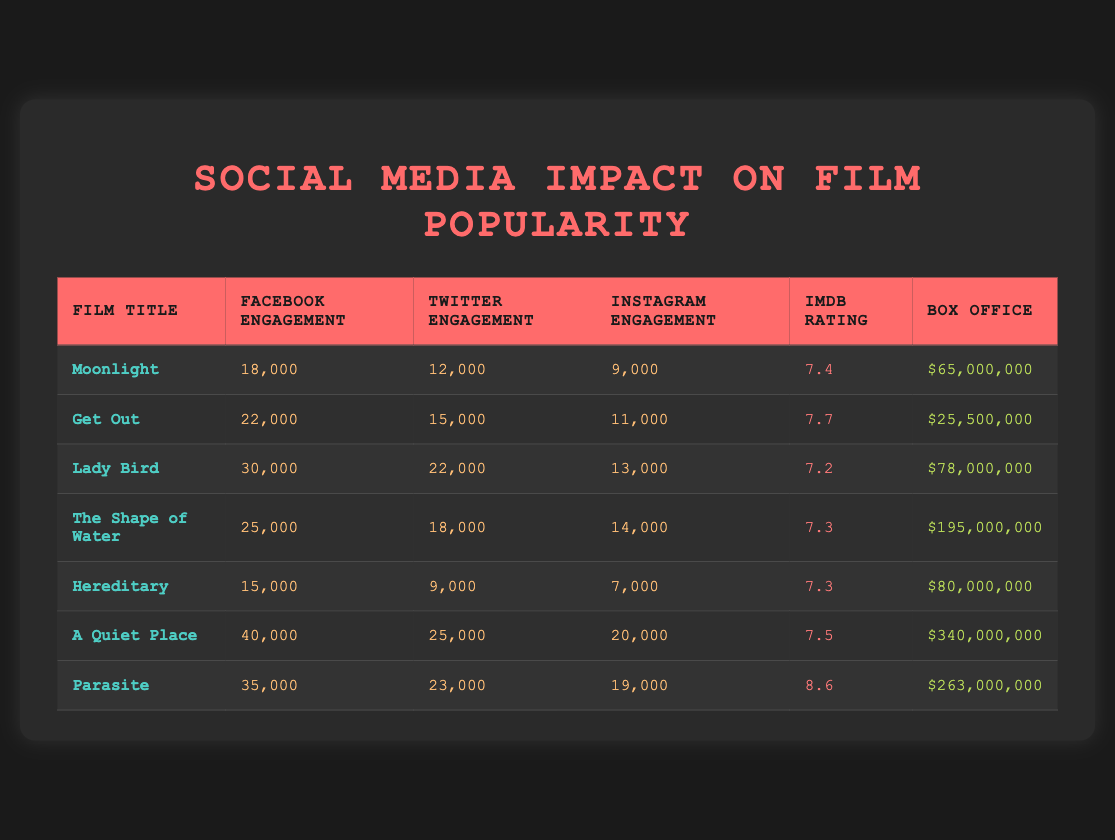What is the box office gross of "A Quiet Place"? The table shows that the box office for "A Quiet Place" is listed as $340,000,000.
Answer: $340,000,000 What film has the highest IMDb rating? By examining the IMDb ratings listed in the table, "Parasite" has the highest rating of 8.6 compared to the other films.
Answer: Parasite Which film had the least engagement on Facebook? Looking at the Facebook engagement values in the table, "Hereditary" has the lowest engagement at 15,000.
Answer: Hereditary What is the total box office gross of the films with an IMDb rating above 7.5? The films with an IMDb rating above 7.5 are "Get Out" (25,500,000), "A Quiet Place" (340,000,000), and "Parasite" (263,000,000). Adding these gives 25,500,000 + 340,000,000 + 263,000,000 = 628,500,000.
Answer: $628,500,000 Is "The Shape of Water" engagement score higher than that of "Get Out"? Comparing the engagement scores, "The Shape of Water" has 25,000 on Facebook and "Get Out" has 22,000, indicating that "The Shape of Water" does indeed have a higher engagement score on Facebook.
Answer: Yes What is the average Instagram engagement for films with an IMDb rating above 7.5? The films with IMDb ratings above 7.5 are "Get Out" (11,000), "A Quiet Place" (20,000), and "Parasite" (19,000). To find the average, sum these values: 11,000 + 20,000 + 19,000 = 50,000, and divide by 3 (50,000 / 3 ≈ 16,667).
Answer: 16,667 Which film had the highest Twitter engagement? The Twitter engagement values show "A Quiet Place" with 25,000 which is higher than all other films listed.
Answer: A Quiet Place Are there any films with more than 30,000 Facebook engagements that also have a box office over 100 million? Checking the table, "A Quiet Place" (40,000 engagement, $340,000,000) and "Parasite" (35,000 engagement, $263,000,000) both have more than 30,000 Facebook engagements and box office gross over 100 million.
Answer: Yes 